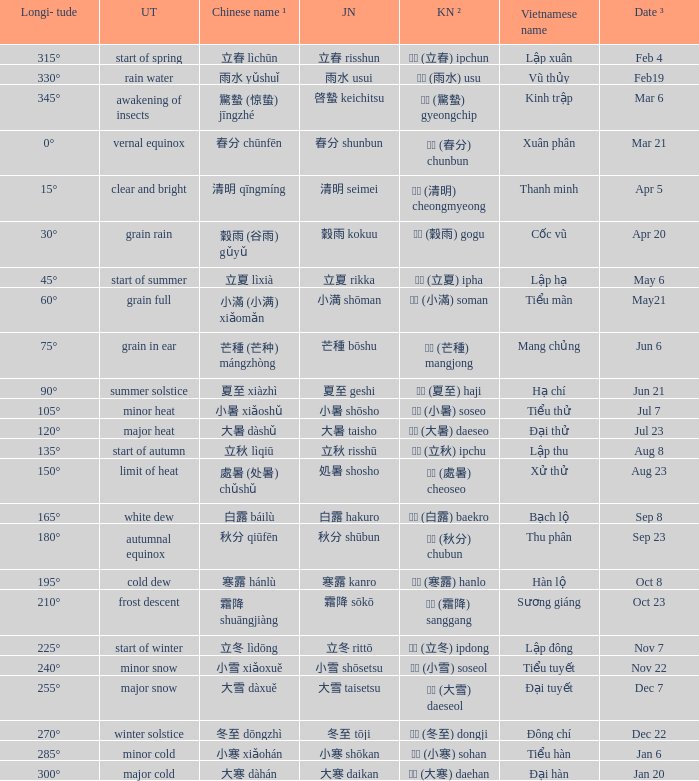Which Longi- tude is on jun 6? 75°. 